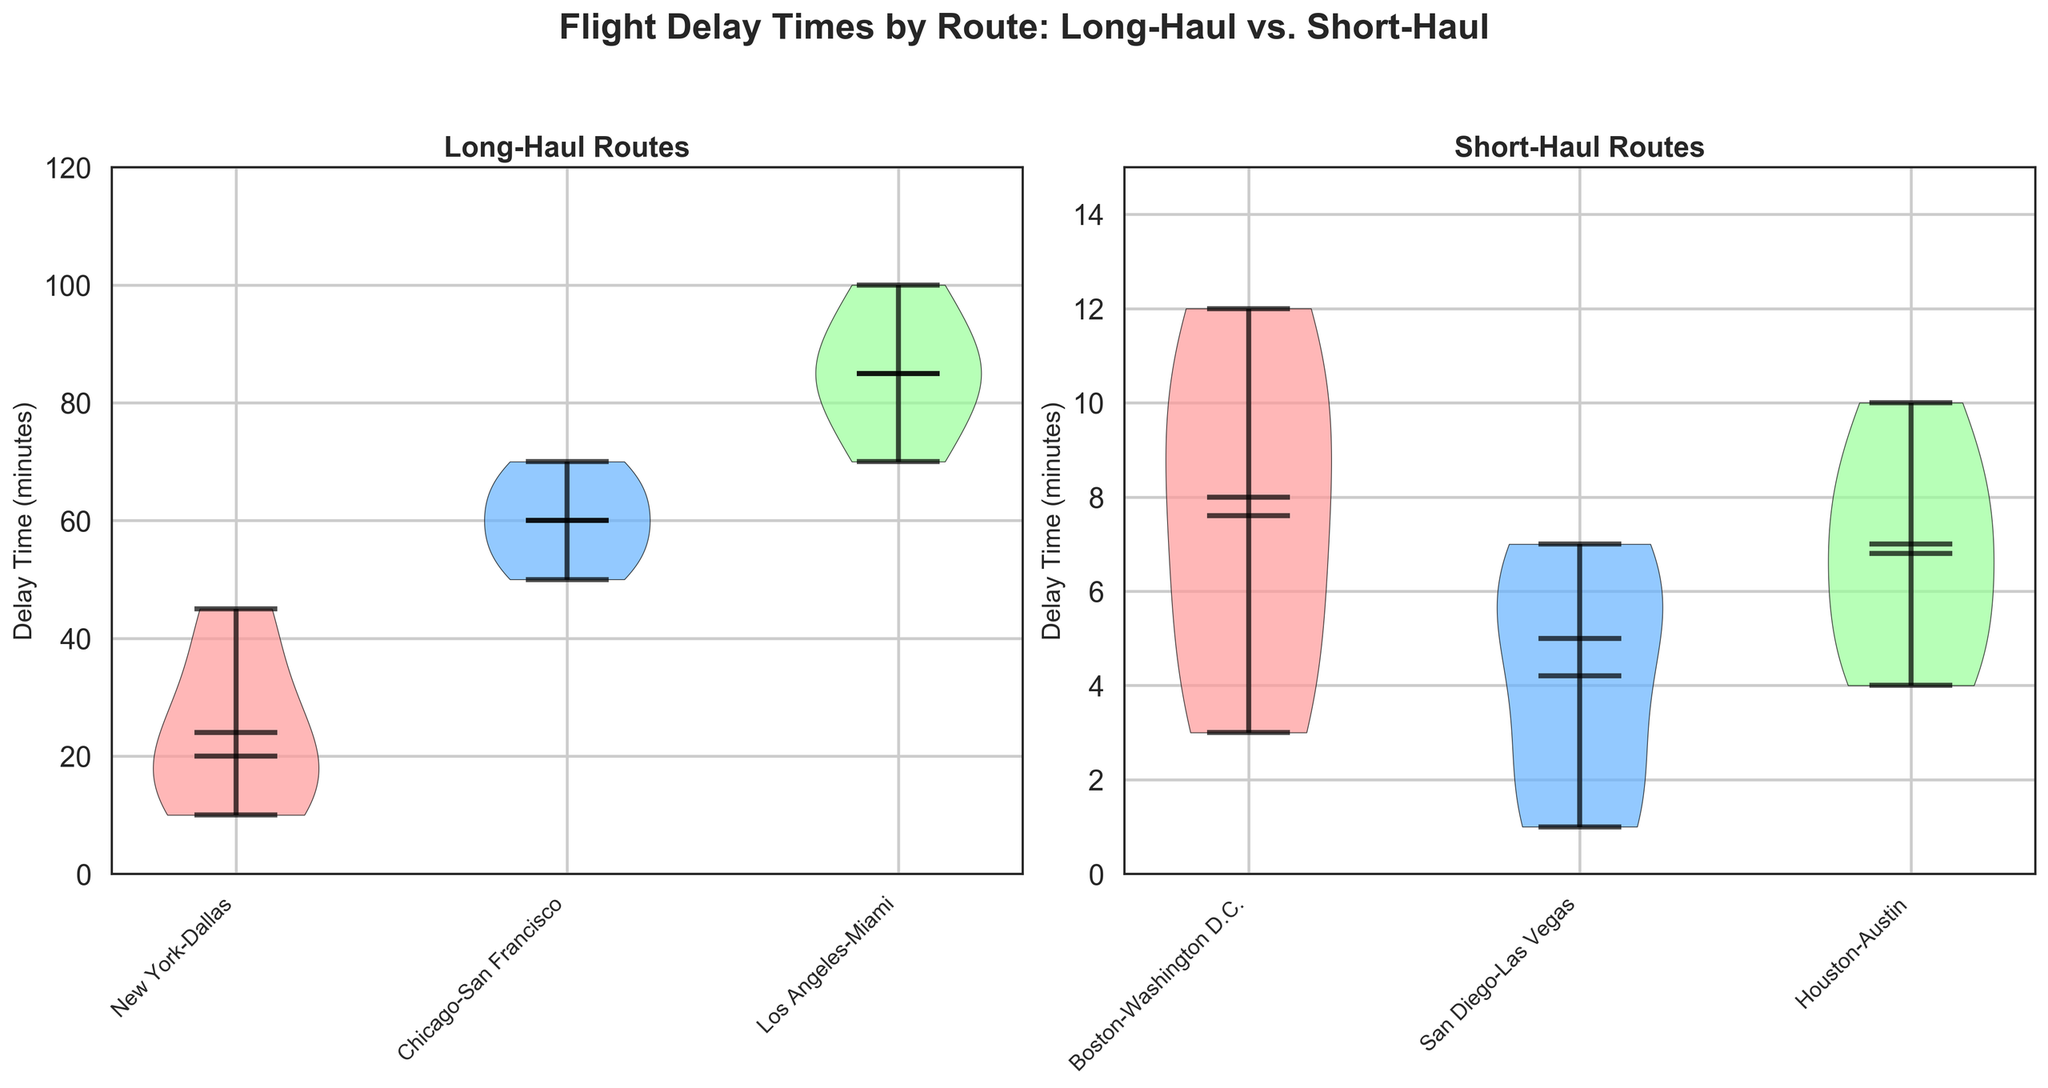What does the figure's title say? The title of the figure is located at the top and it generally summarizes what the figure is about. The title reads "Flight Delay Times by Route: Long-Haul vs. Short-Haul".
Answer: Flight Delay Times by Route: Long-Haul vs. Short-Haul Which axis represents the delay time in minutes? In both subplots, the y-axis represents "Delay Time (minutes)" as indicated by the label on the vertical axes.
Answer: y-axis How many unique long-haul routes are shown in the left subplot? The left subplot represents long-haul routes, with each unique route displayed along the x-axis. Counting these labels identifies 3 routes.
Answer: 3 What is the range of the y-axis for the short-haul routes? The y-axis range for the short-haul routes, indicated by the vertical axis on the right subplot, spans from 0 to 15 minutes.
Answer: 0 to 15 Which long-haul route has the highest median delay time? The subplot on the left shows the median delay time represented by a horizontal line inside each violin plot. The longest median delay time for a long-haul route is between Los Angeles and Miami.
Answer: Los Angeles-Miami How do the delay times for short-haul routes compare to those of long-haul routes in terms of range? The y-axis range for long-haul routes extends to 120 minutes, while for short-haul routes it reaches only 15 minutes, indicating long-haul delays have a broader time range.
Answer: Long-haul delays have a broader time range What is the most common delay time for the Boston-Washington D.C. route? The thickest part of the violin plot for Boston-Washington D.C., which represents the most common delay times, is around 5 to 10 minutes.
Answer: 5 to 10 minutes Which route (long or short-haul) shows the most variability in delay times? The violins representing delay times are wider if there’s more variability. The widest violin in the long-haul subplot is for the Los Angeles-Miami route, showing the most variability.
Answer: Los Angeles-Miami Are the delay times for the Houston-Austin route mostly within a narrower range compared to the New York-Dallas route? Comparing the widths of the violins, the Houston-Austin route in the short-haul subplot is narrower, indicating a more concentrated range of delay times compared to the broader New York-Dallas violin in the long-haul subplot.
Answer: Yes Which short-haul route has the lowest median delay time? The horizontal line representing the median delay time in the right subplot is lowest for the San Diego-Las Vegas route.
Answer: San Diego-Las Vegas 